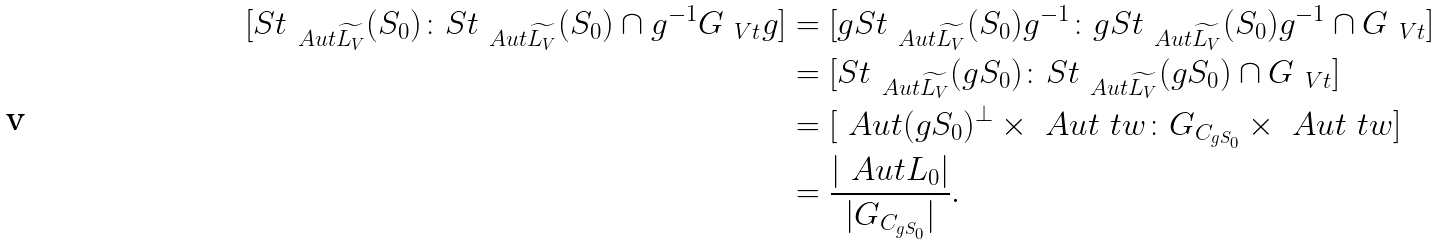Convert formula to latex. <formula><loc_0><loc_0><loc_500><loc_500>[ S t _ { \ A u t \widetilde { L _ { V } } } ( S _ { 0 } ) \colon S t _ { \ A u t \widetilde { L _ { V } } } ( S _ { 0 } ) \cap g ^ { - 1 } G _ { \ V t } g ] & = [ g S t _ { \ A u t \widetilde { L _ { V } } } ( S _ { 0 } ) g ^ { - 1 } \colon g S t _ { \ A u t \widetilde { L _ { V } } } ( S _ { 0 } ) g ^ { - 1 } \cap G _ { \ V t } ] \\ & = [ S t _ { \ A u t \widetilde { L _ { V } } } ( g S _ { 0 } ) \colon S t _ { \ A u t \widetilde { L _ { V } } } ( g S _ { 0 } ) \cap G _ { \ V t } ] \\ & = [ \ A u t ( g S _ { 0 } ) ^ { \perp } \times \ A u t \ t w \colon G _ { C _ { g S _ { 0 } } } \times \ A u t \ t w ] \\ & = \frac { | \ A u t L _ { 0 } | } { | G _ { C _ { g S _ { 0 } } } | } .</formula> 